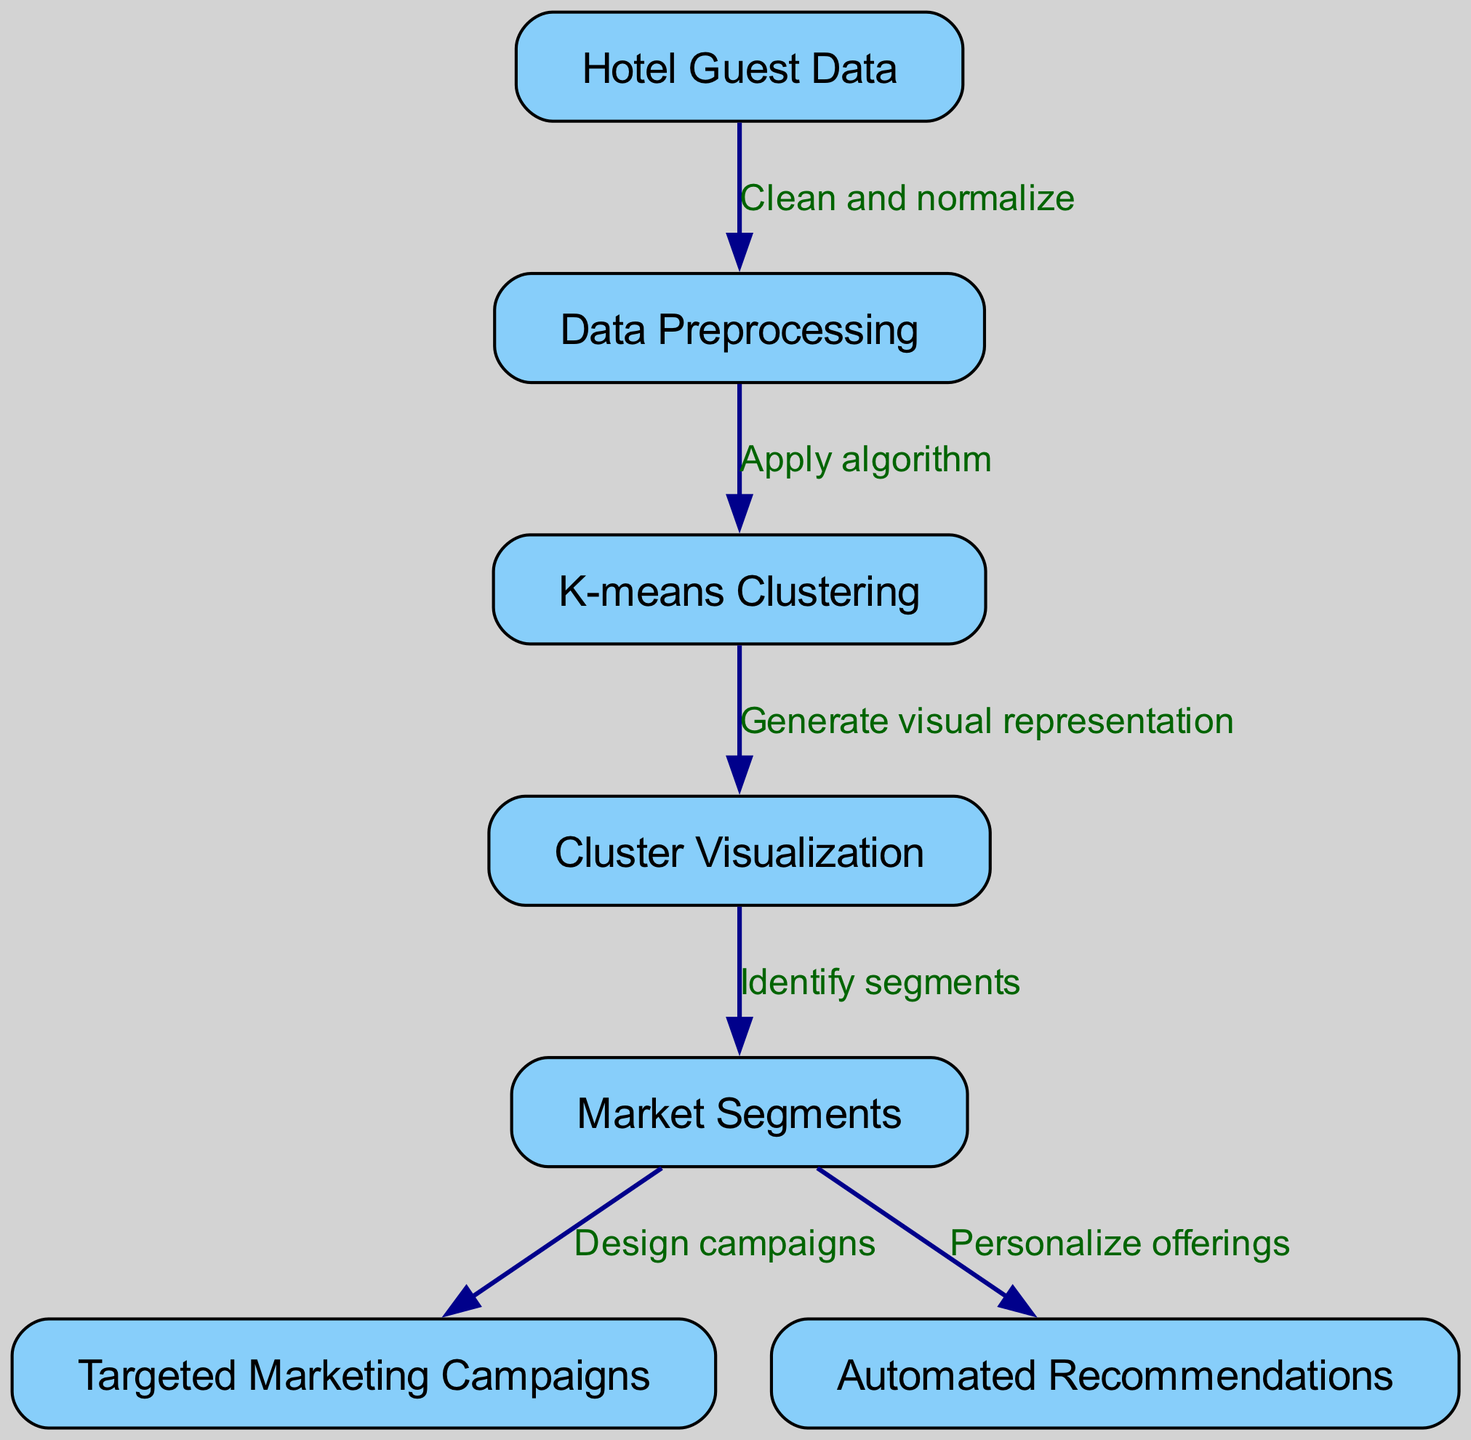What is the first step in the diagram? The first step is represented by the node labeled "Hotel Guest Data," which indicates that the process begins with collecting guest data.
Answer: Hotel Guest Data How many nodes are in the diagram? The diagram includes a total of 7 nodes, as indicated by the different labeled rectangles that represent specific stages in the process.
Answer: 7 What type of edge connects "K-means Clustering" to "Cluster Visualization"? The edge connecting these nodes is labeled "Generate visual representation," indicating the action taken after applying the K-means clustering algorithm.
Answer: Generate visual representation Which node follows "Data Preprocessing"? The node labeled "K-means Clustering" follows "Data Preprocessing," indicating that the algorithm is applied after the data has been cleaned and normalized.
Answer: K-means Clustering What is the relationship between "Market Segments" and "Targeted Marketing Campaigns"? "Market Segments" directly leads to "Targeted Marketing Campaigns" through the edge labeled "Design campaigns," indicating that identified market segments inform the design of marketing strategies.
Answer: Design campaigns Explain the flow from "Hotel Guest Data" to "Automated Recommendations". The flow begins at "Hotel Guest Data," which is processed in "Data Preprocessing" to clean and normalize. After this, "K-means Clustering" is applied to categorize data, followed by "Cluster Visualization" to identify segments. These segments lead to two outcomes: "Targeted Marketing Campaigns," which are designed based on market segments, and "Automated Recommendations," which personalize offerings based on the identified segments.
Answer: Hotel Guest Data → Data Preprocessing → K-means Clustering → Cluster Visualization → Market Segments → Automated Recommendations What action is taken after identifying market segments? After identifying market segments, the next actions include "Design campaigns" for targeted marketing and "Personalize offerings" for automated recommendations, both of which utilize the identified segments.
Answer: Design campaigns, Personalize offerings Is there any edge connecting "Data Preprocessing" to "Market Segments"? No, there is no direct edge connecting "Data Preprocessing" to "Market Segments." The flow proceeds from "Data Preprocessing" to "K-means Clustering," then to "Cluster Visualization," which leads to "Market Segments."
Answer: No 